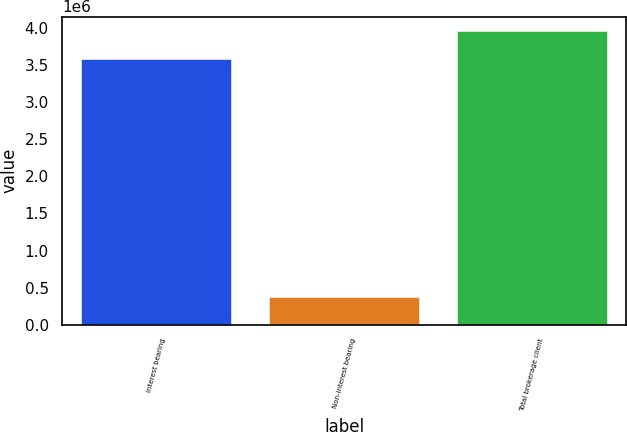<chart> <loc_0><loc_0><loc_500><loc_500><bar_chart><fcel>Interest bearing<fcel>Non-interest bearing<fcel>Total brokerage client<nl><fcel>3.5781e+06<fcel>378003<fcel>3.9561e+06<nl></chart> 